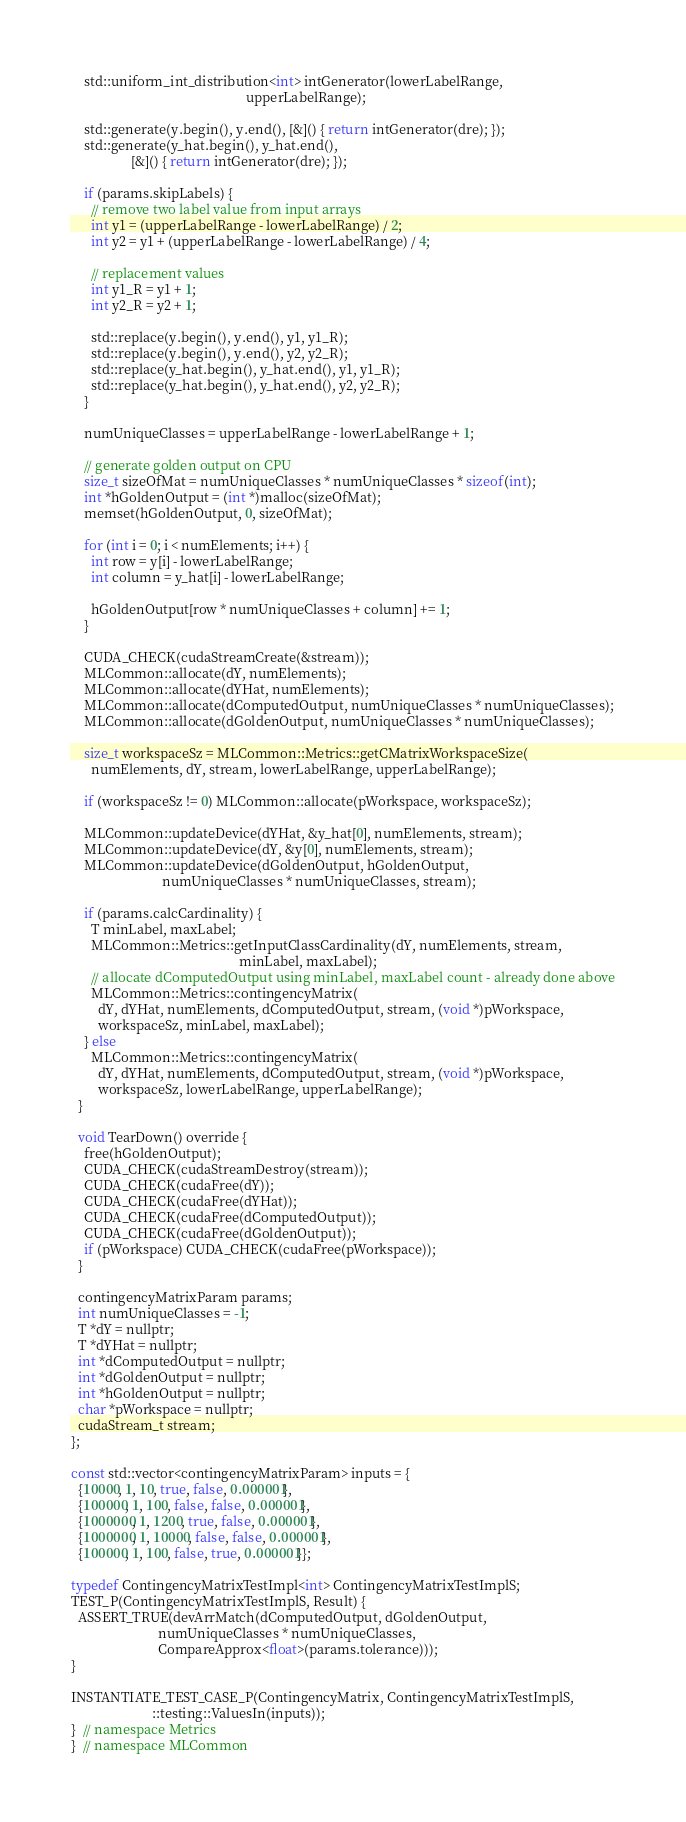<code> <loc_0><loc_0><loc_500><loc_500><_Cuda_>    std::uniform_int_distribution<int> intGenerator(lowerLabelRange,
                                                    upperLabelRange);

    std::generate(y.begin(), y.end(), [&]() { return intGenerator(dre); });
    std::generate(y_hat.begin(), y_hat.end(),
                  [&]() { return intGenerator(dre); });

    if (params.skipLabels) {
      // remove two label value from input arrays
      int y1 = (upperLabelRange - lowerLabelRange) / 2;
      int y2 = y1 + (upperLabelRange - lowerLabelRange) / 4;

      // replacement values
      int y1_R = y1 + 1;
      int y2_R = y2 + 1;

      std::replace(y.begin(), y.end(), y1, y1_R);
      std::replace(y.begin(), y.end(), y2, y2_R);
      std::replace(y_hat.begin(), y_hat.end(), y1, y1_R);
      std::replace(y_hat.begin(), y_hat.end(), y2, y2_R);
    }

    numUniqueClasses = upperLabelRange - lowerLabelRange + 1;

    // generate golden output on CPU
    size_t sizeOfMat = numUniqueClasses * numUniqueClasses * sizeof(int);
    int *hGoldenOutput = (int *)malloc(sizeOfMat);
    memset(hGoldenOutput, 0, sizeOfMat);

    for (int i = 0; i < numElements; i++) {
      int row = y[i] - lowerLabelRange;
      int column = y_hat[i] - lowerLabelRange;

      hGoldenOutput[row * numUniqueClasses + column] += 1;
    }

    CUDA_CHECK(cudaStreamCreate(&stream));
    MLCommon::allocate(dY, numElements);
    MLCommon::allocate(dYHat, numElements);
    MLCommon::allocate(dComputedOutput, numUniqueClasses * numUniqueClasses);
    MLCommon::allocate(dGoldenOutput, numUniqueClasses * numUniqueClasses);

    size_t workspaceSz = MLCommon::Metrics::getCMatrixWorkspaceSize(
      numElements, dY, stream, lowerLabelRange, upperLabelRange);

    if (workspaceSz != 0) MLCommon::allocate(pWorkspace, workspaceSz);

    MLCommon::updateDevice(dYHat, &y_hat[0], numElements, stream);
    MLCommon::updateDevice(dY, &y[0], numElements, stream);
    MLCommon::updateDevice(dGoldenOutput, hGoldenOutput,
                           numUniqueClasses * numUniqueClasses, stream);

    if (params.calcCardinality) {
      T minLabel, maxLabel;
      MLCommon::Metrics::getInputClassCardinality(dY, numElements, stream,
                                                  minLabel, maxLabel);
      // allocate dComputedOutput using minLabel, maxLabel count - already done above
      MLCommon::Metrics::contingencyMatrix(
        dY, dYHat, numElements, dComputedOutput, stream, (void *)pWorkspace,
        workspaceSz, minLabel, maxLabel);
    } else
      MLCommon::Metrics::contingencyMatrix(
        dY, dYHat, numElements, dComputedOutput, stream, (void *)pWorkspace,
        workspaceSz, lowerLabelRange, upperLabelRange);
  }

  void TearDown() override {
    free(hGoldenOutput);
    CUDA_CHECK(cudaStreamDestroy(stream));
    CUDA_CHECK(cudaFree(dY));
    CUDA_CHECK(cudaFree(dYHat));
    CUDA_CHECK(cudaFree(dComputedOutput));
    CUDA_CHECK(cudaFree(dGoldenOutput));
    if (pWorkspace) CUDA_CHECK(cudaFree(pWorkspace));
  }

  contingencyMatrixParam params;
  int numUniqueClasses = -1;
  T *dY = nullptr;
  T *dYHat = nullptr;
  int *dComputedOutput = nullptr;
  int *dGoldenOutput = nullptr;
  int *hGoldenOutput = nullptr;
  char *pWorkspace = nullptr;
  cudaStream_t stream;
};

const std::vector<contingencyMatrixParam> inputs = {
  {10000, 1, 10, true, false, 0.000001},
  {100000, 1, 100, false, false, 0.000001},
  {1000000, 1, 1200, true, false, 0.000001},
  {1000000, 1, 10000, false, false, 0.000001},
  {100000, 1, 100, false, true, 0.000001}};

typedef ContingencyMatrixTestImpl<int> ContingencyMatrixTestImplS;
TEST_P(ContingencyMatrixTestImplS, Result) {
  ASSERT_TRUE(devArrMatch(dComputedOutput, dGoldenOutput,
                          numUniqueClasses * numUniqueClasses,
                          CompareApprox<float>(params.tolerance)));
}

INSTANTIATE_TEST_CASE_P(ContingencyMatrix, ContingencyMatrixTestImplS,
                        ::testing::ValuesIn(inputs));
}  // namespace Metrics
}  // namespace MLCommon
</code> 